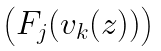<formula> <loc_0><loc_0><loc_500><loc_500>\begin{pmatrix} F _ { j } ( v _ { k } ( z ) ) \end{pmatrix}</formula> 